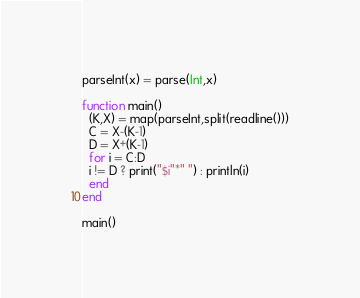<code> <loc_0><loc_0><loc_500><loc_500><_Julia_>parseInt(x) = parse(Int,x)

function main()
  (K,X) = map(parseInt,split(readline()))
  C = X-(K-1)
  D = X+(K-1)
  for i = C:D
  i != D ? print("$i"*" ") : println(i)
  end
end

main()</code> 